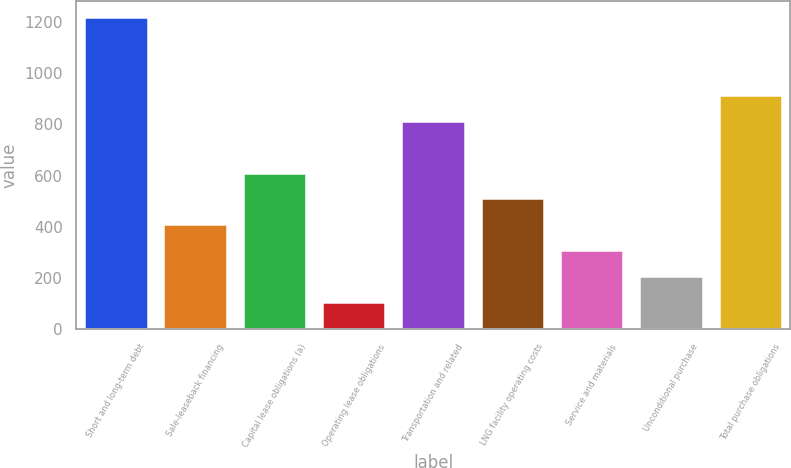<chart> <loc_0><loc_0><loc_500><loc_500><bar_chart><fcel>Short and long-term debt<fcel>Sale-leaseback financing<fcel>Capital lease obligations (a)<fcel>Operating lease obligations<fcel>Transportation and related<fcel>LNG facility operating costs<fcel>Service and materials<fcel>Unconditional purchase<fcel>Total purchase obligations<nl><fcel>1219.4<fcel>409.8<fcel>612.2<fcel>106.2<fcel>814.6<fcel>511<fcel>308.6<fcel>207.4<fcel>915.8<nl></chart> 